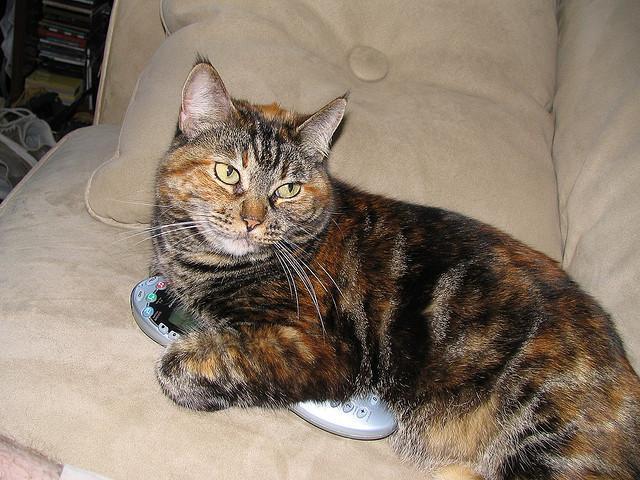How many remotes are there?
Give a very brief answer. 2. 